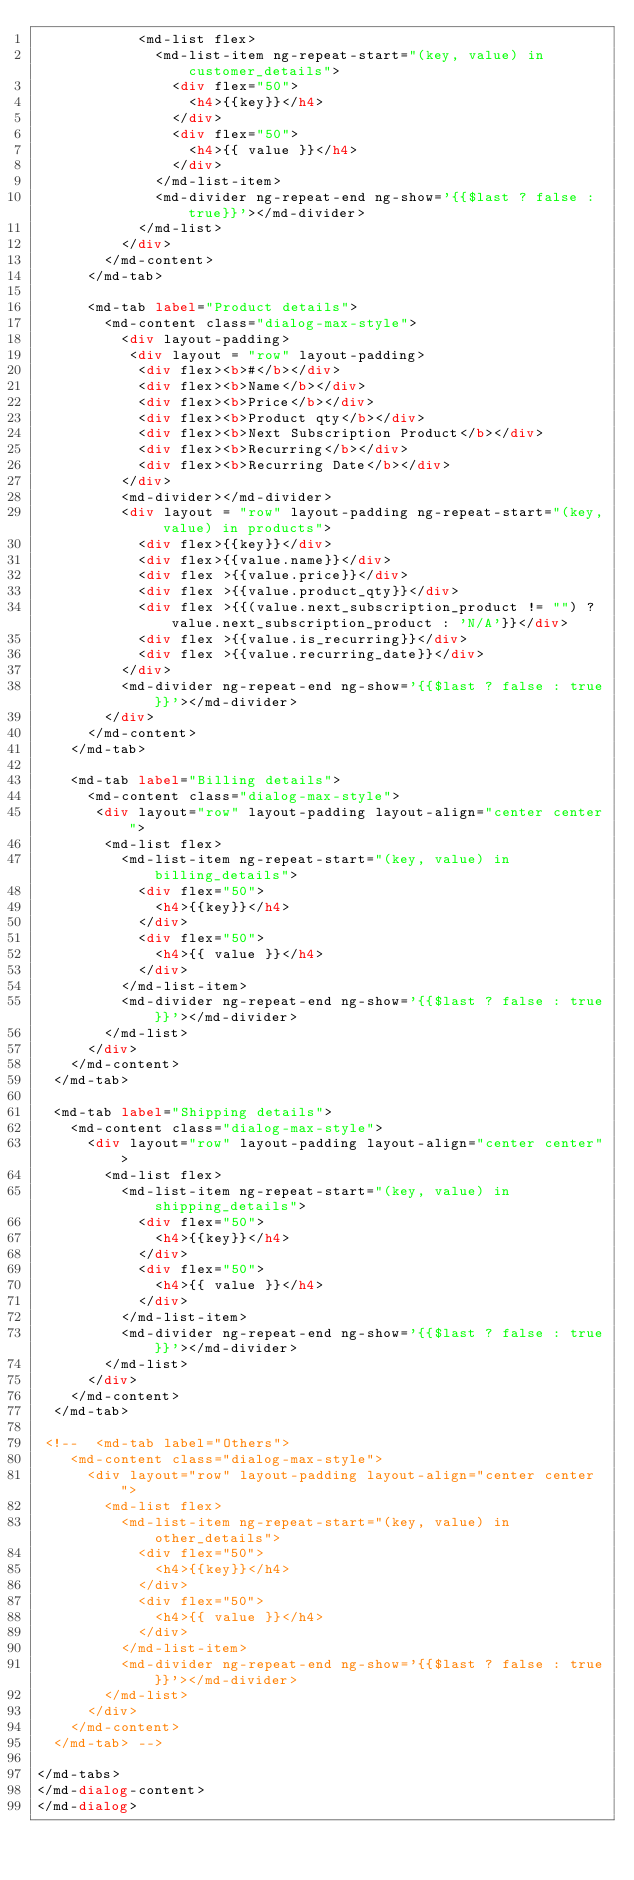<code> <loc_0><loc_0><loc_500><loc_500><_HTML_>            <md-list flex>
              <md-list-item ng-repeat-start="(key, value) in customer_details">
                <div flex="50">
                  <h4>{{key}}</h4>
                </div>
                <div flex="50">
                  <h4>{{ value }}</h4>
                </div>
              </md-list-item>
              <md-divider ng-repeat-end ng-show='{{$last ? false : true}}'></md-divider>
            </md-list>
          </div>
        </md-content>
      </md-tab>

      <md-tab label="Product details">
        <md-content class="dialog-max-style">
          <div layout-padding>
           <div layout = "row" layout-padding>
            <div flex><b>#</b></div>
            <div flex><b>Name</b></div>
            <div flex><b>Price</b></div>
            <div flex><b>Product qty</b></div>
            <div flex><b>Next Subscription Product</b></div>
            <div flex><b>Recurring</b></div>
            <div flex><b>Recurring Date</b></div>
          </div>
          <md-divider></md-divider>
          <div layout = "row" layout-padding ng-repeat-start="(key, value) in products">
            <div flex>{{key}}</div>
            <div flex>{{value.name}}</div>
            <div flex >{{value.price}}</div>
            <div flex >{{value.product_qty}}</div>
            <div flex >{{(value.next_subscription_product != "") ? value.next_subscription_product : 'N/A'}}</div>
            <div flex >{{value.is_recurring}}</div>
            <div flex >{{value.recurring_date}}</div>
          </div>
          <md-divider ng-repeat-end ng-show='{{$last ? false : true}}'></md-divider>
        </div>
      </md-content>
    </md-tab>

    <md-tab label="Billing details">
      <md-content class="dialog-max-style">
       <div layout="row" layout-padding layout-align="center center">
        <md-list flex>
          <md-list-item ng-repeat-start="(key, value) in billing_details">
            <div flex="50">
              <h4>{{key}}</h4>
            </div>
            <div flex="50">
              <h4>{{ value }}</h4>
            </div>
          </md-list-item>
          <md-divider ng-repeat-end ng-show='{{$last ? false : true}}'></md-divider>
        </md-list>
      </div>
    </md-content>
  </md-tab>

  <md-tab label="Shipping details">
    <md-content class="dialog-max-style">
      <div layout="row" layout-padding layout-align="center center">
        <md-list flex>
          <md-list-item ng-repeat-start="(key, value) in shipping_details">
            <div flex="50">
              <h4>{{key}}</h4>
            </div>
            <div flex="50">
              <h4>{{ value }}</h4>
            </div>
          </md-list-item>
          <md-divider ng-repeat-end ng-show='{{$last ? false : true}}'></md-divider>
        </md-list>
      </div>
    </md-content>
  </md-tab>

 <!--  <md-tab label="Others">
    <md-content class="dialog-max-style">
      <div layout="row" layout-padding layout-align="center center">
        <md-list flex>
          <md-list-item ng-repeat-start="(key, value) in other_details">
            <div flex="50">
              <h4>{{key}}</h4>
            </div>
            <div flex="50">
              <h4>{{ value }}</h4>
            </div>
          </md-list-item>
          <md-divider ng-repeat-end ng-show='{{$last ? false : true}}'></md-divider>
        </md-list>
      </div>
    </md-content>
  </md-tab> -->

</md-tabs>
</md-dialog-content>
</md-dialog></code> 